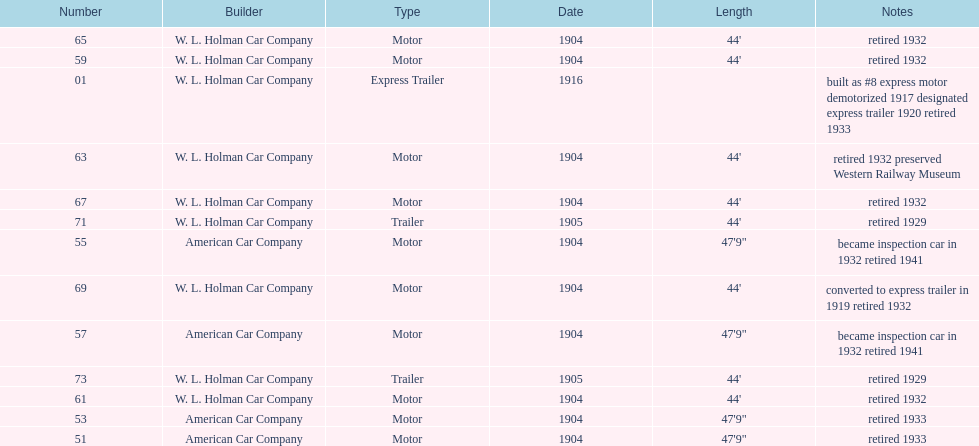Did american car company or w.l. holman car company build cars that were 44' in length? W. L. Holman Car Company. 